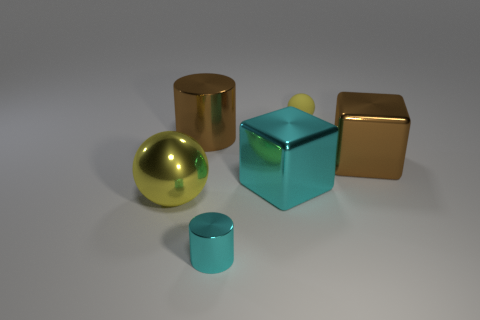There is a large shiny thing that is to the left of the brown cylinder; what color is it?
Provide a short and direct response. Yellow. How big is the thing that is in front of the small yellow rubber thing and right of the big cyan metal object?
Keep it short and to the point. Large. Does the large yellow thing have the same material as the tiny thing in front of the big cylinder?
Make the answer very short. Yes. What number of other yellow things have the same shape as the big yellow metallic object?
Keep it short and to the point. 1. What material is the big ball that is the same color as the small sphere?
Provide a succinct answer. Metal. What number of small gray matte balls are there?
Your answer should be very brief. 0. Is the shape of the big yellow shiny thing the same as the tiny thing that is right of the cyan cube?
Your answer should be very brief. Yes. What number of things are small green shiny spheres or things that are on the left side of the yellow rubber ball?
Your answer should be compact. 4. There is a large yellow thing that is the same shape as the tiny matte thing; what is its material?
Your response must be concise. Metal. There is a yellow thing that is to the right of the large cyan metallic block; does it have the same shape as the tiny shiny thing?
Provide a short and direct response. No. 